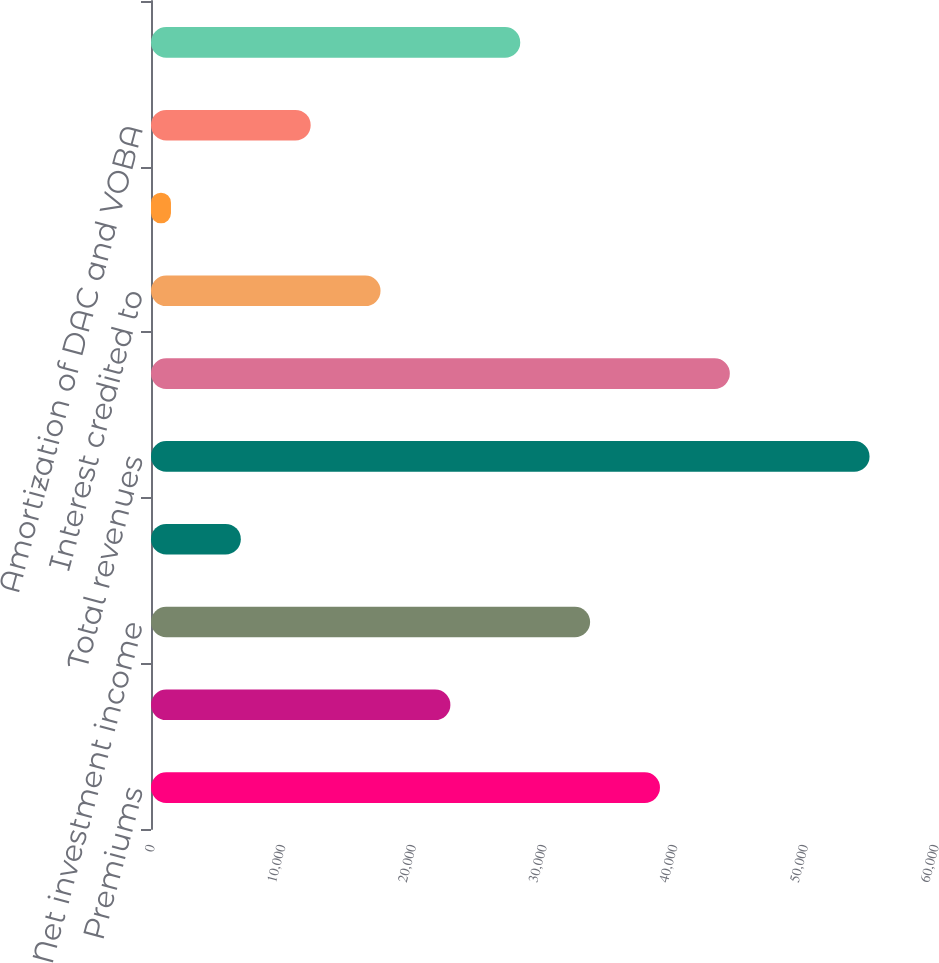Convert chart to OTSL. <chart><loc_0><loc_0><loc_500><loc_500><bar_chart><fcel>Premiums<fcel>Universal life and<fcel>Net investment income<fcel>Other revenues<fcel>Total revenues<fcel>Policyholder benefits and<fcel>Interest credited to<fcel>Capitalization of DAC<fcel>Amortization of DAC and VOBA<fcel>Other expenses<nl><fcel>38952.1<fcel>22913.2<fcel>33605.8<fcel>6874.3<fcel>54991<fcel>44298.4<fcel>17566.9<fcel>1528<fcel>12220.6<fcel>28259.5<nl></chart> 